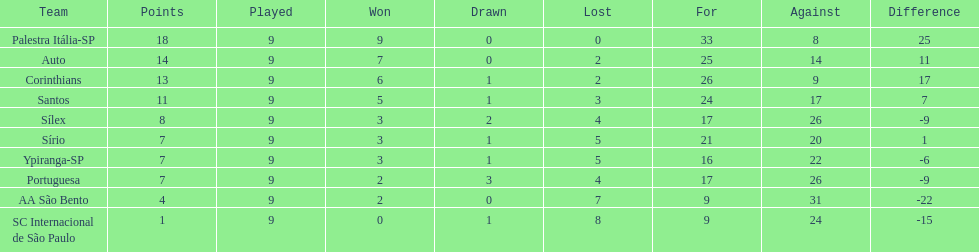Which team was the only team that was undefeated? Palestra Itália-SP. Could you parse the entire table as a dict? {'header': ['Team', 'Points', 'Played', 'Won', 'Drawn', 'Lost', 'For', 'Against', 'Difference'], 'rows': [['Palestra Itália-SP', '18', '9', '9', '0', '0', '33', '8', '25'], ['Auto', '14', '9', '7', '0', '2', '25', '14', '11'], ['Corinthians', '13', '9', '6', '1', '2', '26', '9', '17'], ['Santos', '11', '9', '5', '1', '3', '24', '17', '7'], ['Sílex', '8', '9', '3', '2', '4', '17', '26', '-9'], ['Sírio', '7', '9', '3', '1', '5', '21', '20', '1'], ['Ypiranga-SP', '7', '9', '3', '1', '5', '16', '22', '-6'], ['Portuguesa', '7', '9', '2', '3', '4', '17', '26', '-9'], ['AA São Bento', '4', '9', '2', '0', '7', '9', '31', '-22'], ['SC Internacional de São Paulo', '1', '9', '0', '1', '8', '9', '24', '-15']]} 